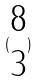Convert formula to latex. <formula><loc_0><loc_0><loc_500><loc_500>( \begin{matrix} 8 \\ 3 \end{matrix} )</formula> 